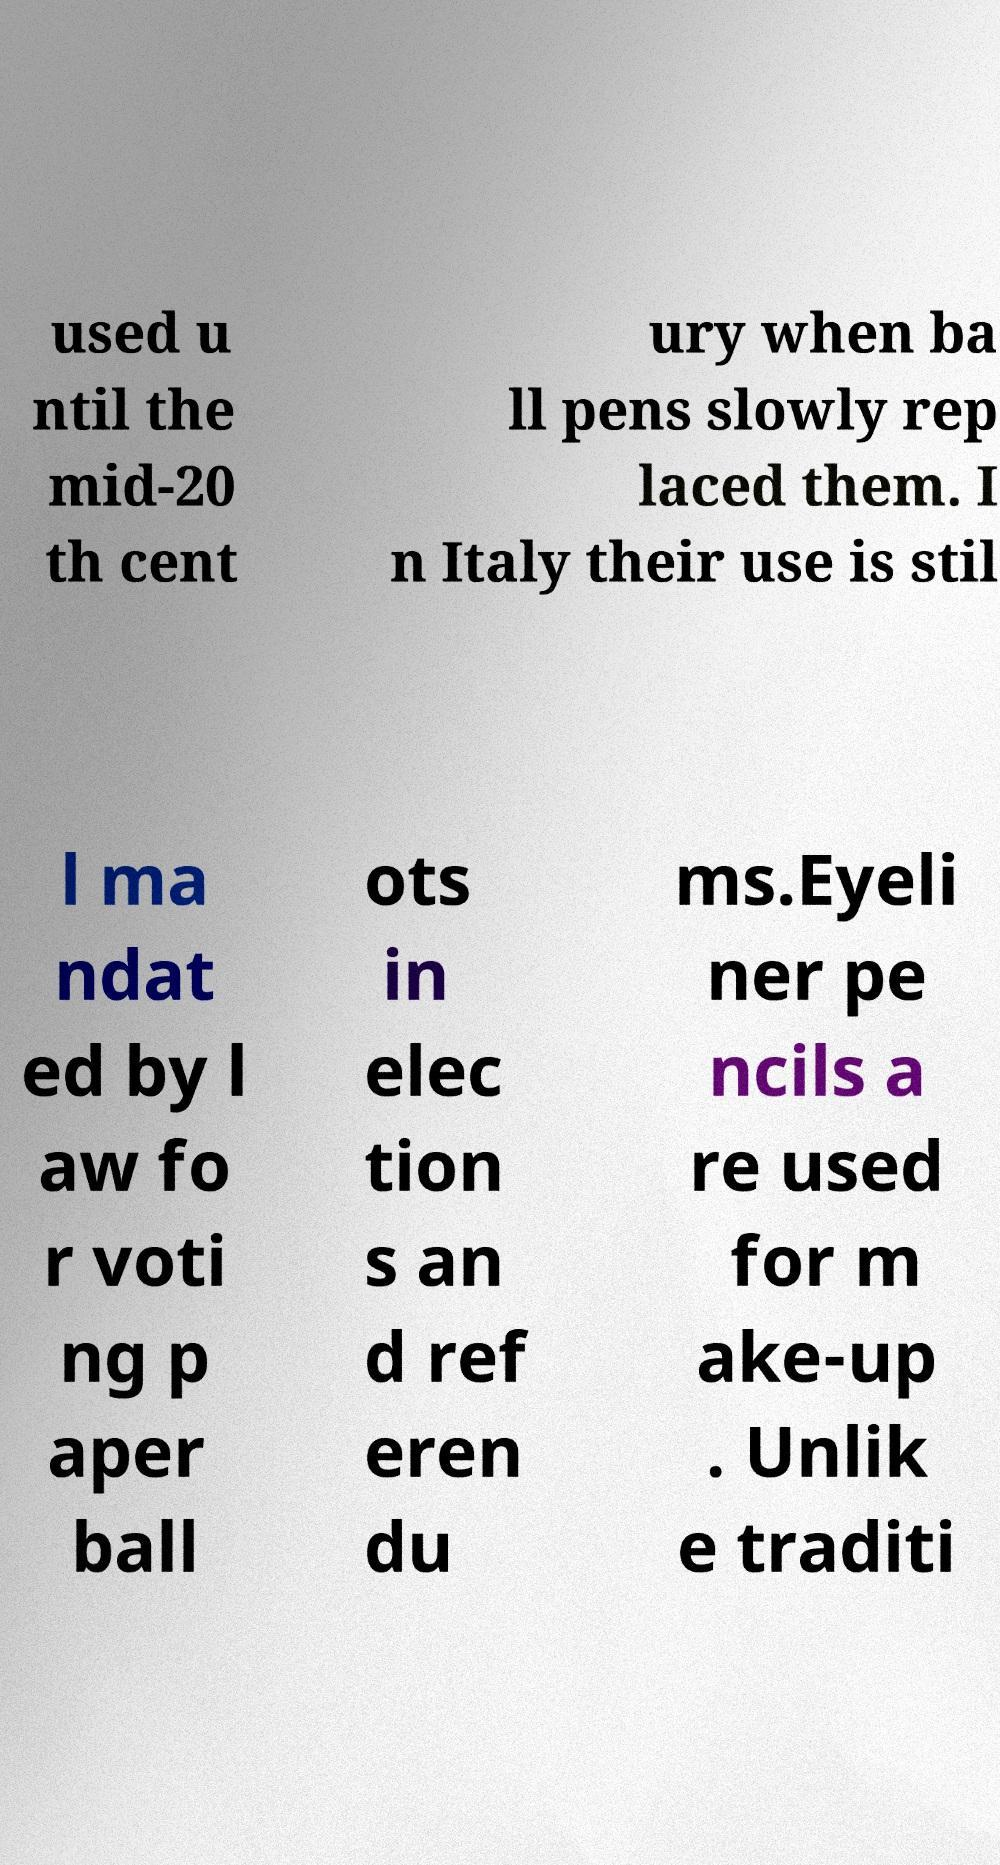Can you read and provide the text displayed in the image?This photo seems to have some interesting text. Can you extract and type it out for me? used u ntil the mid-20 th cent ury when ba ll pens slowly rep laced them. I n Italy their use is stil l ma ndat ed by l aw fo r voti ng p aper ball ots in elec tion s an d ref eren du ms.Eyeli ner pe ncils a re used for m ake-up . Unlik e traditi 